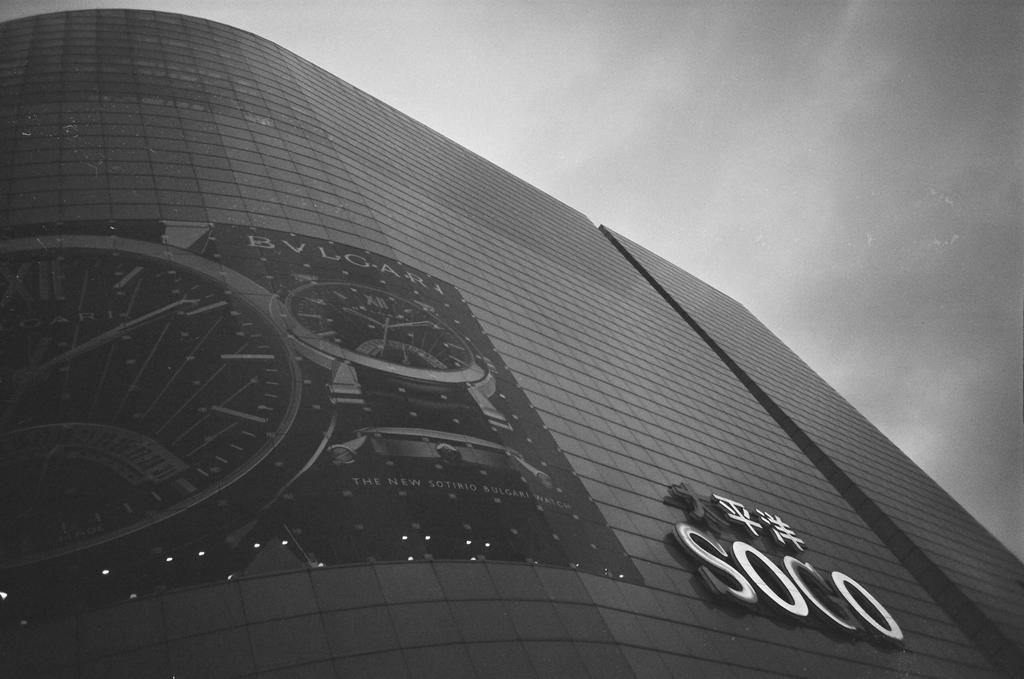What is the color scheme of the image? The image is black and white. What is the main subject of the image? There is a building in the image. Are there any words or letters on the building? Yes, there is writing on the building. What can be seen in the background of the image? There is a cloudy sky in the background of the image. What type of organization is responsible for the acoustics in the building shown in the image? There is no information about an organization or acoustics in the image; it only shows a building with writing on it and a cloudy sky in the background. 